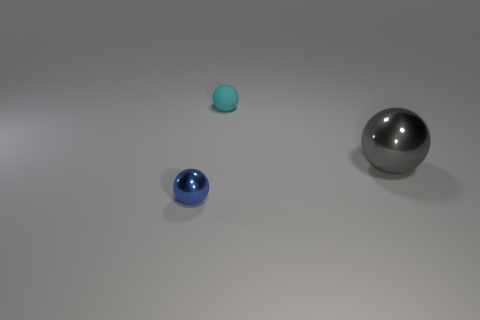What number of tiny blue things are made of the same material as the large object?
Keep it short and to the point. 1. Are there fewer balls than big brown shiny things?
Provide a succinct answer. No. There is a sphere behind the large metal sphere; is its color the same as the big shiny object?
Give a very brief answer. No. There is a ball that is on the right side of the small thing that is right of the tiny metallic ball; how many large shiny spheres are in front of it?
Provide a succinct answer. 0. How many small balls are on the left side of the cyan matte ball?
Make the answer very short. 1. There is a large metal thing that is the same shape as the tiny cyan thing; what color is it?
Offer a terse response. Gray. The ball that is behind the tiny blue metal ball and left of the big gray sphere is made of what material?
Make the answer very short. Rubber. There is a object on the right side of the cyan ball; is its size the same as the small cyan matte thing?
Your answer should be compact. No. What material is the blue object?
Your answer should be compact. Metal. What color is the object behind the big gray ball?
Offer a terse response. Cyan. 